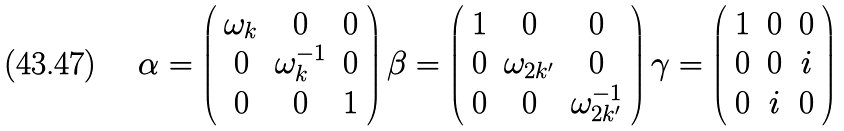Convert formula to latex. <formula><loc_0><loc_0><loc_500><loc_500>\alpha = \left ( \begin{array} { c c c } { { \omega _ { k } } } & { 0 } & { 0 } \\ { 0 } & { { \omega _ { k } ^ { - 1 } } } & { 0 } \\ { 0 } & { 0 } & { 1 } \end{array} \right ) \beta = \left ( \begin{array} { c c c } { 1 } & { 0 } & { 0 } \\ { 0 } & { { \omega _ { 2 k ^ { \prime } } } } & { 0 } \\ { 0 } & { 0 } & { { \omega _ { 2 k ^ { \prime } } ^ { - 1 } } } \end{array} \right ) \gamma = \left ( \begin{array} { c c c } { 1 } & { 0 } & { 0 } \\ { 0 } & { 0 } & { i } \\ { 0 } & { i } & { 0 } \end{array} \right )</formula> 